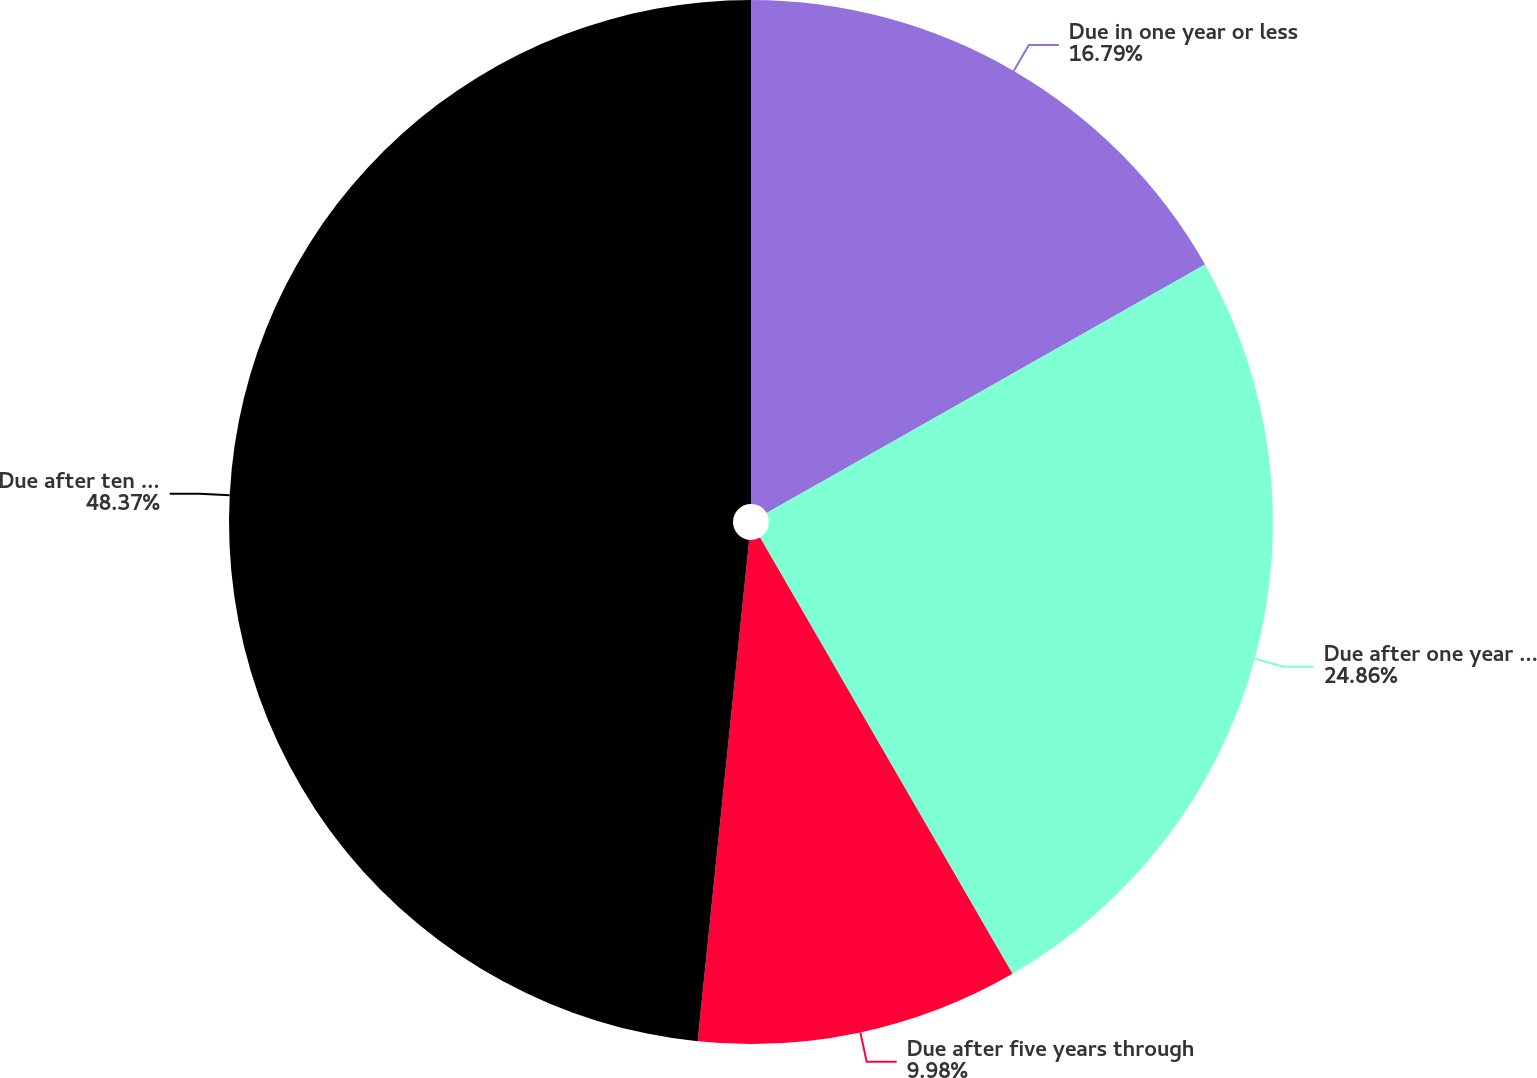Convert chart to OTSL. <chart><loc_0><loc_0><loc_500><loc_500><pie_chart><fcel>Due in one year or less<fcel>Due after one year through<fcel>Due after five years through<fcel>Due after ten years<nl><fcel>16.79%<fcel>24.86%<fcel>9.98%<fcel>48.37%<nl></chart> 